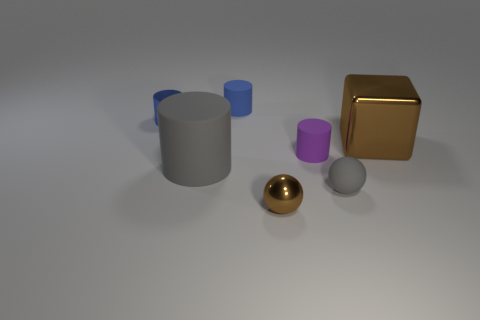Subtract all matte cylinders. How many cylinders are left? 1 Add 1 blue metal things. How many objects exist? 8 Subtract all gray balls. How many balls are left? 1 Subtract all cylinders. How many objects are left? 3 Add 5 small metal cylinders. How many small metal cylinders exist? 6 Subtract 1 brown cubes. How many objects are left? 6 Subtract 1 blocks. How many blocks are left? 0 Subtract all red cylinders. Subtract all yellow blocks. How many cylinders are left? 4 Subtract all red balls. How many yellow cylinders are left? 0 Subtract all tiny brown metal balls. Subtract all purple rubber cylinders. How many objects are left? 5 